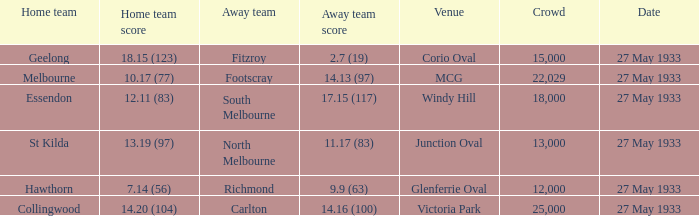During st kilda's home match, what was the quantity of individuals in the audience? 13000.0. 